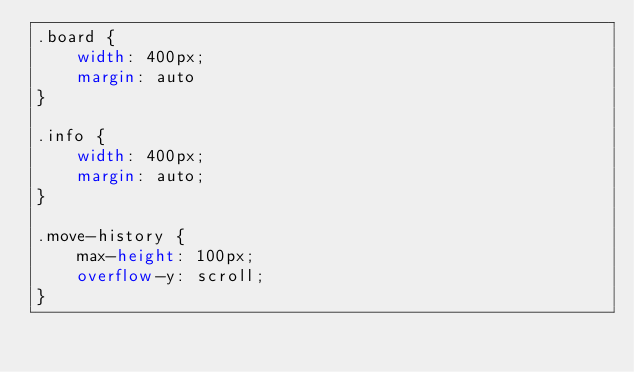<code> <loc_0><loc_0><loc_500><loc_500><_CSS_>.board {
    width: 400px;
    margin: auto
}

.info {
    width: 400px;
    margin: auto;
}

.move-history {
    max-height: 100px;
    overflow-y: scroll;
}</code> 